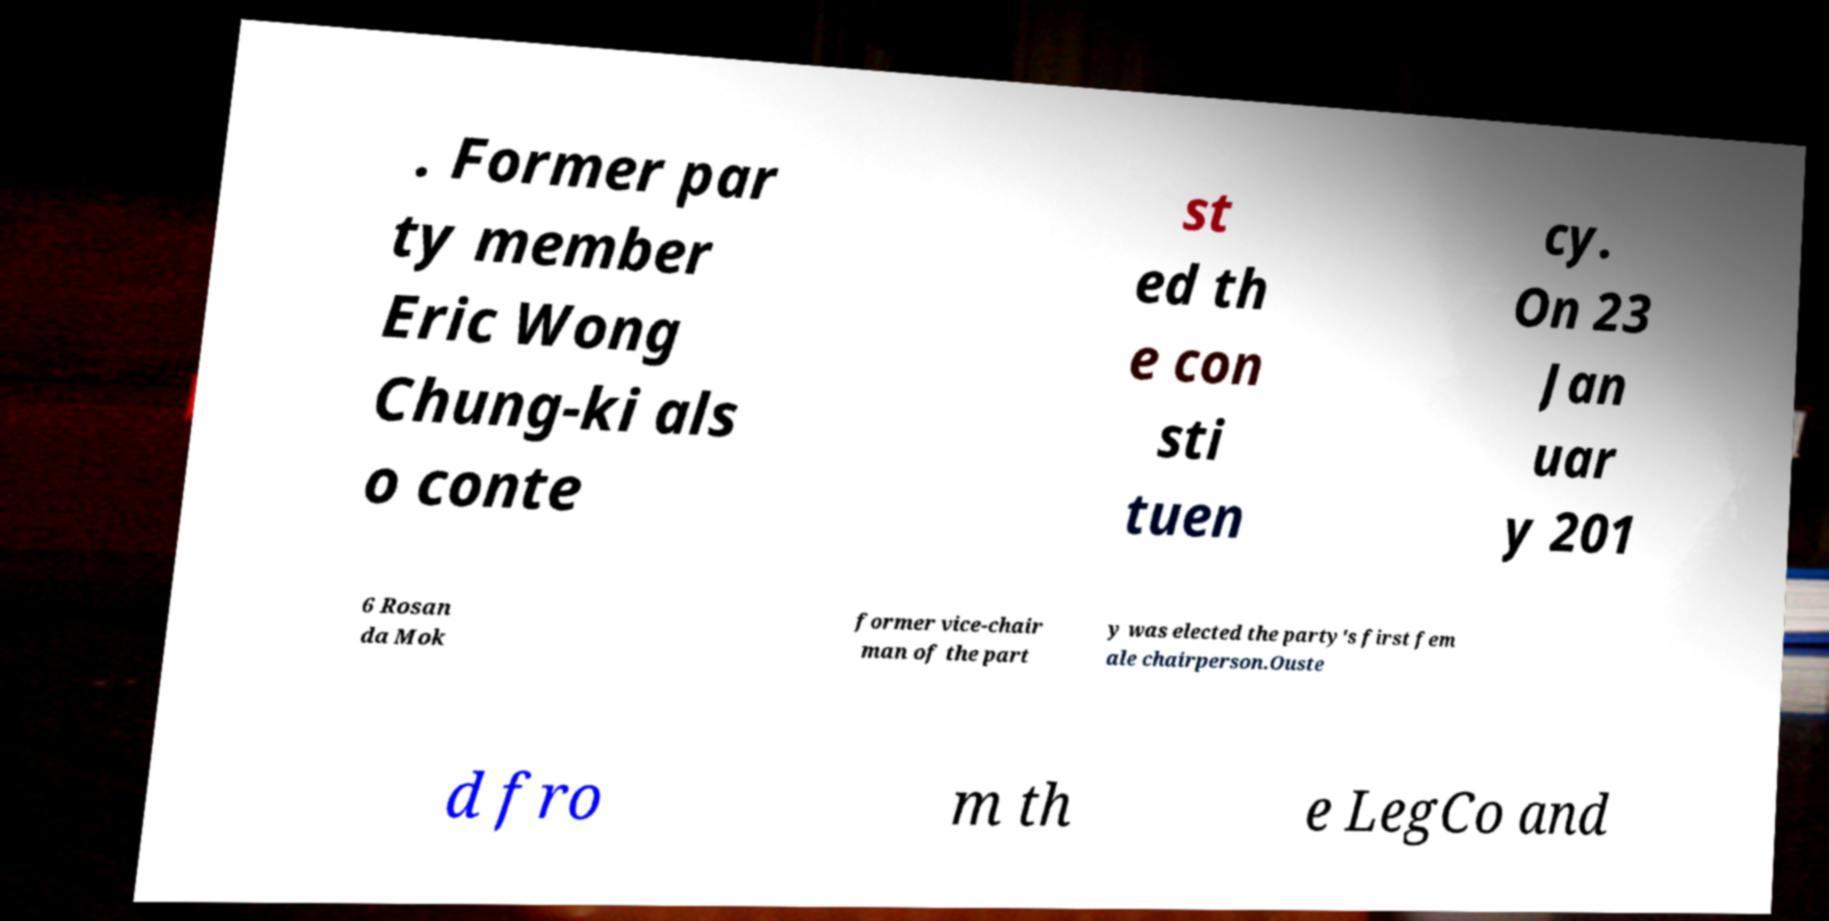Can you accurately transcribe the text from the provided image for me? . Former par ty member Eric Wong Chung-ki als o conte st ed th e con sti tuen cy. On 23 Jan uar y 201 6 Rosan da Mok former vice-chair man of the part y was elected the party's first fem ale chairperson.Ouste d fro m th e LegCo and 